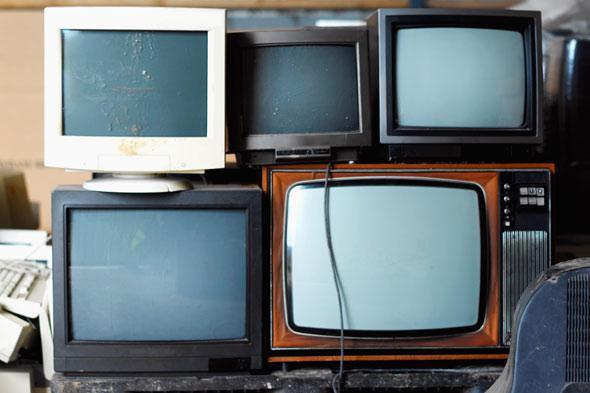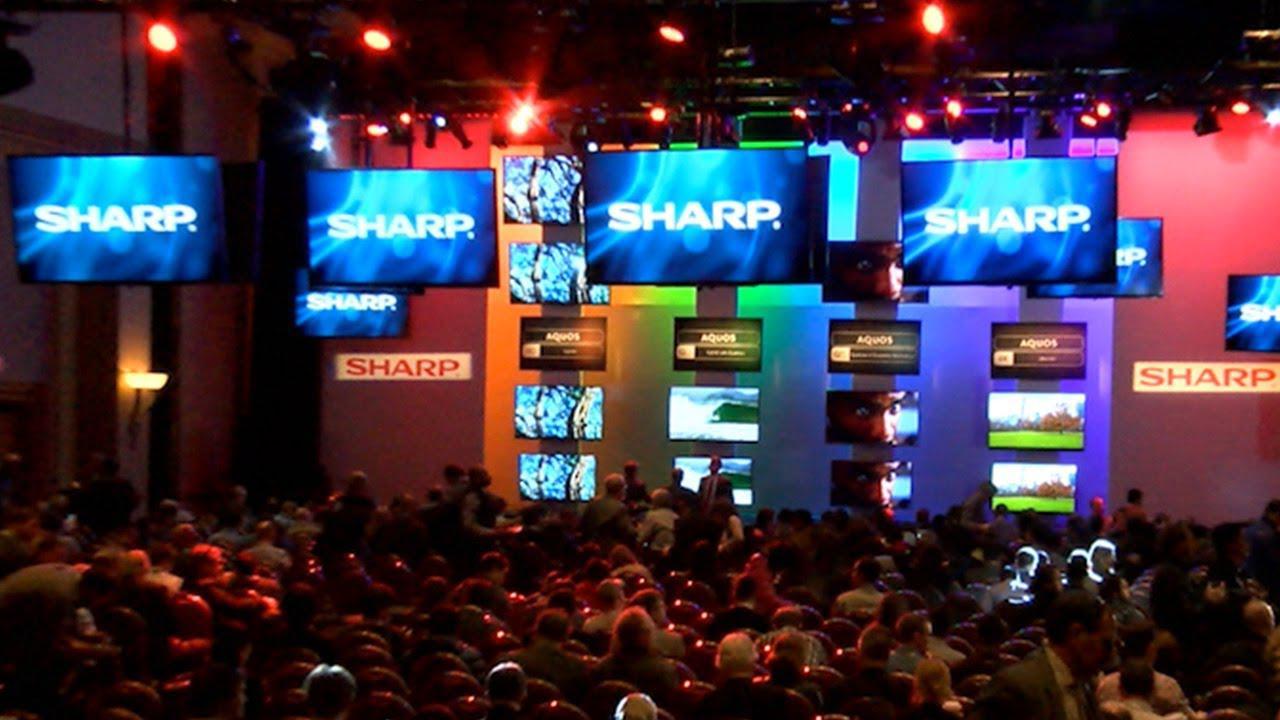The first image is the image on the left, the second image is the image on the right. Examine the images to the left and right. Is the description "An image shows at least four stacked rows that include non-flatscreen type TVs." accurate? Answer yes or no. No. The first image is the image on the left, the second image is the image on the right. For the images shown, is this caption "One of the images shows a group of at least ten vintage television sets." true? Answer yes or no. No. 